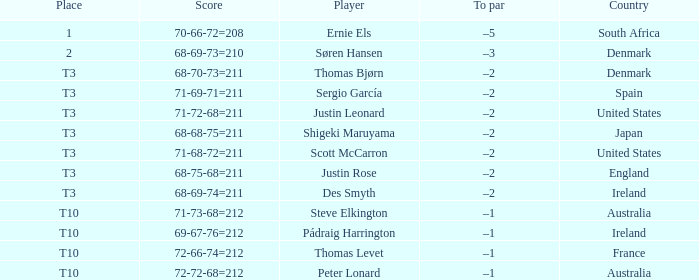What was Australia's score when Peter Lonard played? 72-72-68=212. 